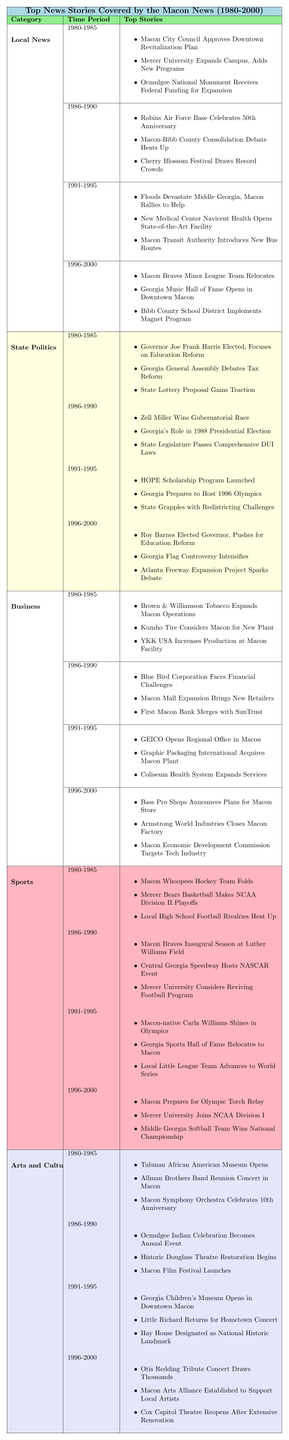What were the top stories in Local News during 1986-1990? From the table under the Local News category for the time period 1986-1990, the top stories listed are: "Robins Air Force Base Celebrates 50th Anniversary," "Macon-Bibb County Consolidation Debate Heats Up," and "Cherry Blossom Festival Draws Record Crowds."
Answer: Robins Air Force Base Celebrates 50th Anniversary, Macon-Bibb County Consolidation Debate Heats Up, Cherry Blossom Festival Draws Record Crowds Which category had the most stories listed from 1991-1995? By looking at the table, each category has three stories listed for 1991-1995; therefore, all categories are equally represented in this time period.
Answer: All categories had the same number of stories Did the Macon Braves change locations during the 1996-2000 period? According to the table under Local News from 1996-2000, one of the top stories is "Macon Braves Minor League Team Relocates," indicating that they did indeed change locations.
Answer: Yes Which year saw the opening of the Tubman African American Museum? The table shows that the Tubman African American Museum opened in the 1980-1985 period under Arts and Culture.
Answer: 1980-1985 How many stories are listed for State Politics during the 1996-2000 period? In the State Politics category for the years 1996-2000, the table lists three stories: "Roy Barnes Elected Governor, Pushes for Education Reform," "Georgia Flag Controversy Intensifies," and "Atlanta Freeway Expansion Project Sparks Debate." Therefore, there are three stories listed.
Answer: 3 What is the majority focus of the Business category between 1986-1990? Looking at the Business category for 1986-1990, the stories primarily reflect challenges and developments in local businesses, with a specific mention of "Blue Bird Corporation Faces Financial Challenges," indicating that it was a critical focus.
Answer: Challenges in local businesses Compare the number of Arts and Culture stories in the 1980-1985 period with those in the 1996-2000 period. The 1980-1985 period has three stories listed: "Tubman African American Museum Opens," "Allman Brothers Band Reunion Concert in Macon," and "Macon Symphony Orchestra Celebrates 10th Anniversary." In contrast, the 1996-2000 period lists three stories as well: "Otis Redding Tribute Concert Draws Thousands," "Macon Arts Alliance Established to Support Local Artists," and "Cox Capitol Theatre Reopens After Extensive Renovation." Therefore, both periods have an equal number of stories.
Answer: Both periods have three stories What major event related to education occurred in State Politics during 1991-1995? The table shows that during the 1991-1995 period, the launch of the HOPE Scholarship Program was a significant event related to education in State Politics.
Answer: Launch of the HOPE Scholarship Program Was there a change in the number of stories related to sports between 1980-1985 and 1996-2000? In both time periods of 1980-1985 and 1996-2000, there are three stories listed for Sports: one from each period detailing local sports events and achievements. Therefore, there was no change in the number of stories.
Answer: No change in the number of stories What is the focus of the top stories listed in the Business category during 1996-2000? In the Business category for 1996-2000, the stories focus on economic developments and business activity in Macon, including "Bass Pro Shops Announces Plans for Macon Store," "Armstrong World Industries Closes Macon Factory," and "Macon Economic Development Commission Targets Tech Industry." This indicates a focus on new developments and economic strategies.
Answer: Economic developments and business activity 